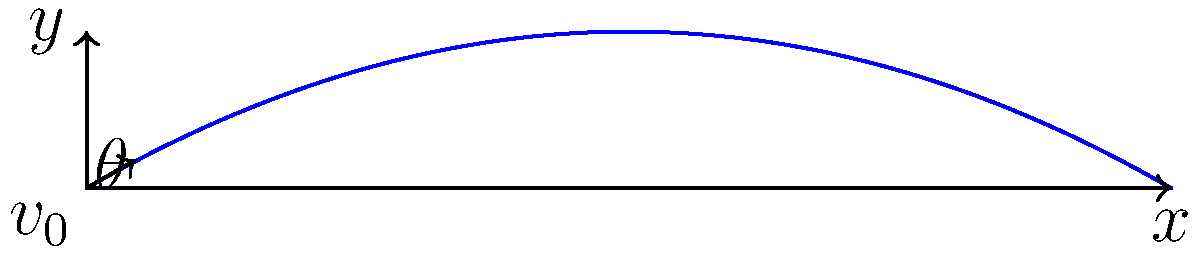As a physics professor, you're demonstrating projectile motion to your students. A projectile is launched from ground level with an initial velocity of 50 m/s at an angle of 30° above the horizontal. Neglecting air resistance, what is the maximum height reached by the projectile? Express your answer in meters, rounded to two decimal places. Let's approach this step-by-step:

1) The maximum height of a projectile is reached when its vertical velocity becomes zero. We can find this using the equation:

   $$y_{max} = \frac{v_0^2 \sin^2 \theta}{2g}$$

   Where:
   $y_{max}$ is the maximum height
   $v_0$ is the initial velocity
   $\theta$ is the launch angle
   $g$ is the acceleration due to gravity (9.8 m/s²)

2) We're given:
   $v_0 = 50$ m/s
   $\theta = 30°$
   $g = 9.8$ m/s²

3) First, let's convert the angle to radians:
   $$30° = 30 \times \frac{\pi}{180} = \frac{\pi}{6}$$ radians

4) Now, let's substitute these values into our equation:

   $$y_{max} = \frac{(50)^2 \sin^2 (\frac{\pi}{6})}{2(9.8)}$$

5) Simplify:
   $$y_{max} = \frac{2500 \times 0.25}{19.6} = 31.8877...$$ m

6) Rounding to two decimal places:
   $$y_{max} \approx 31.89$$ m

Therefore, the maximum height reached by the projectile is approximately 31.89 meters.
Answer: 31.89 m 